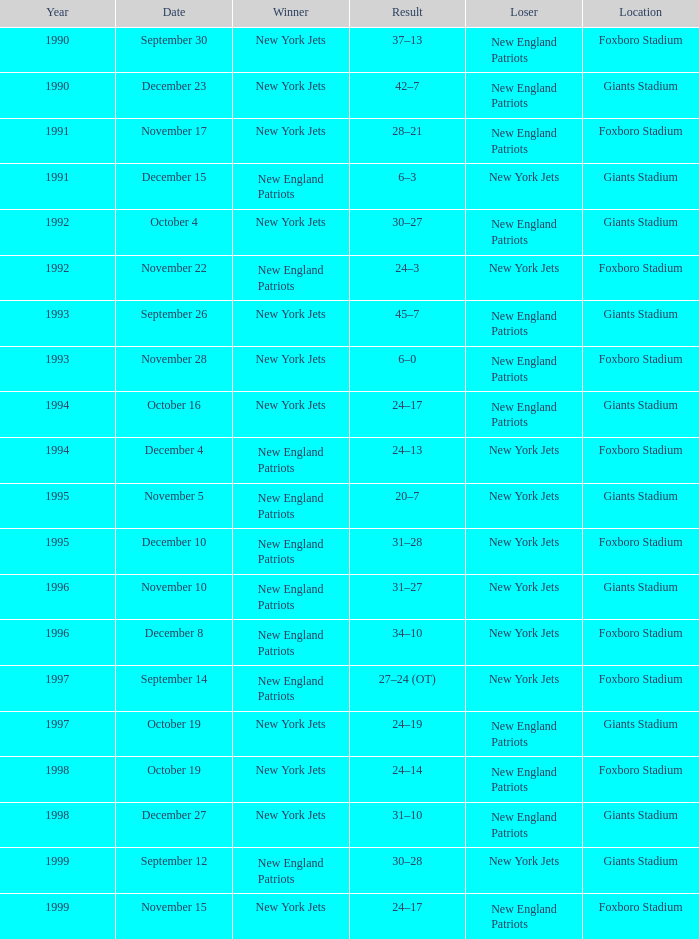What year did the new york jets have a 24-17 win at giants stadium? 1994.0. 